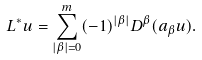<formula> <loc_0><loc_0><loc_500><loc_500>L ^ { * } u = \sum _ { | \beta | = 0 } ^ { m } ( - 1 ) ^ { | \beta | } D ^ { \beta } ( a _ { \beta } u ) .</formula> 